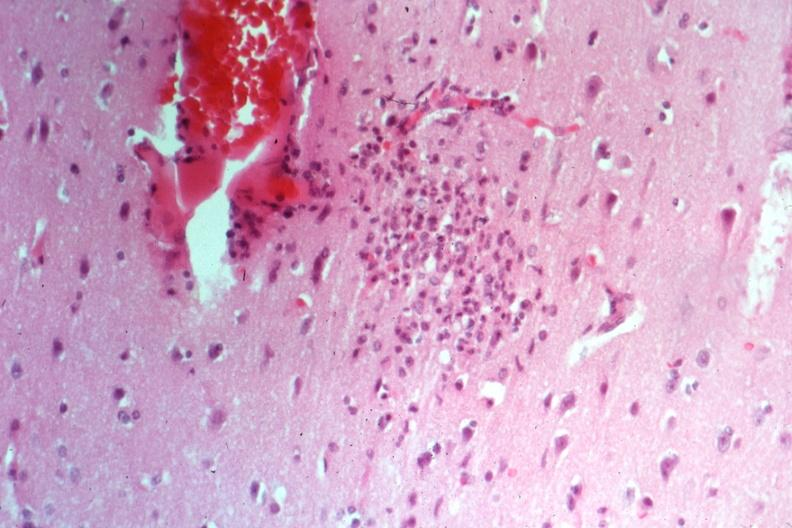s glial nodule present?
Answer the question using a single word or phrase. Yes 